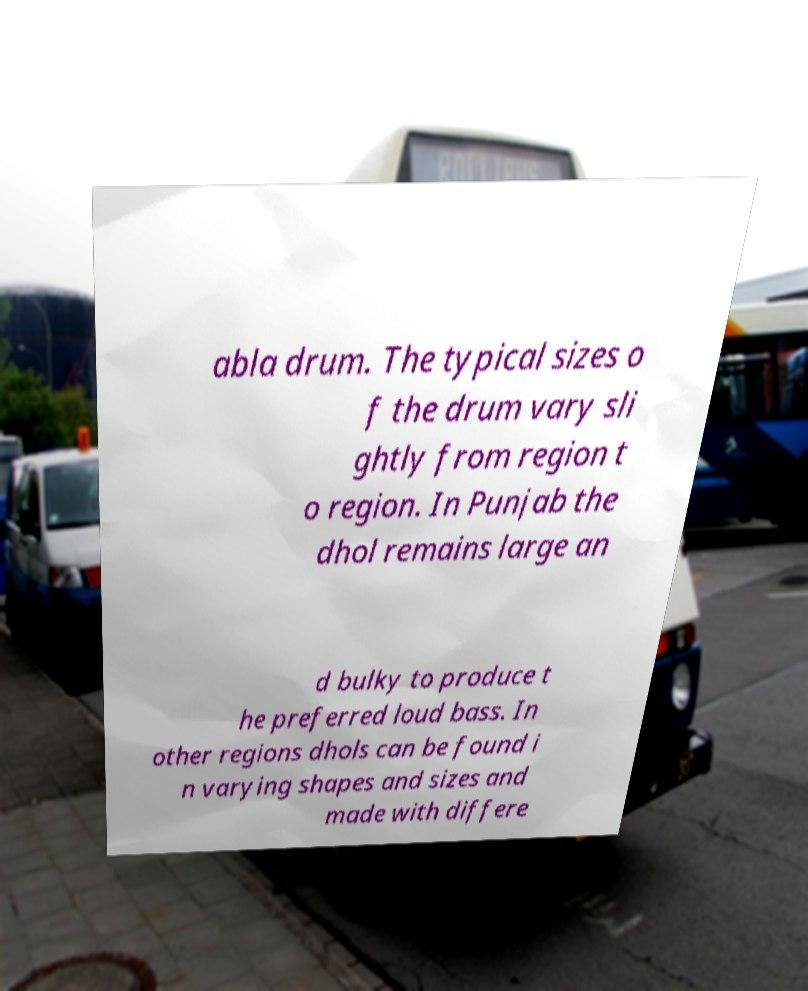I need the written content from this picture converted into text. Can you do that? abla drum. The typical sizes o f the drum vary sli ghtly from region t o region. In Punjab the dhol remains large an d bulky to produce t he preferred loud bass. In other regions dhols can be found i n varying shapes and sizes and made with differe 